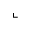Convert formula to latex. <formula><loc_0><loc_0><loc_500><loc_500>\llcorner</formula> 